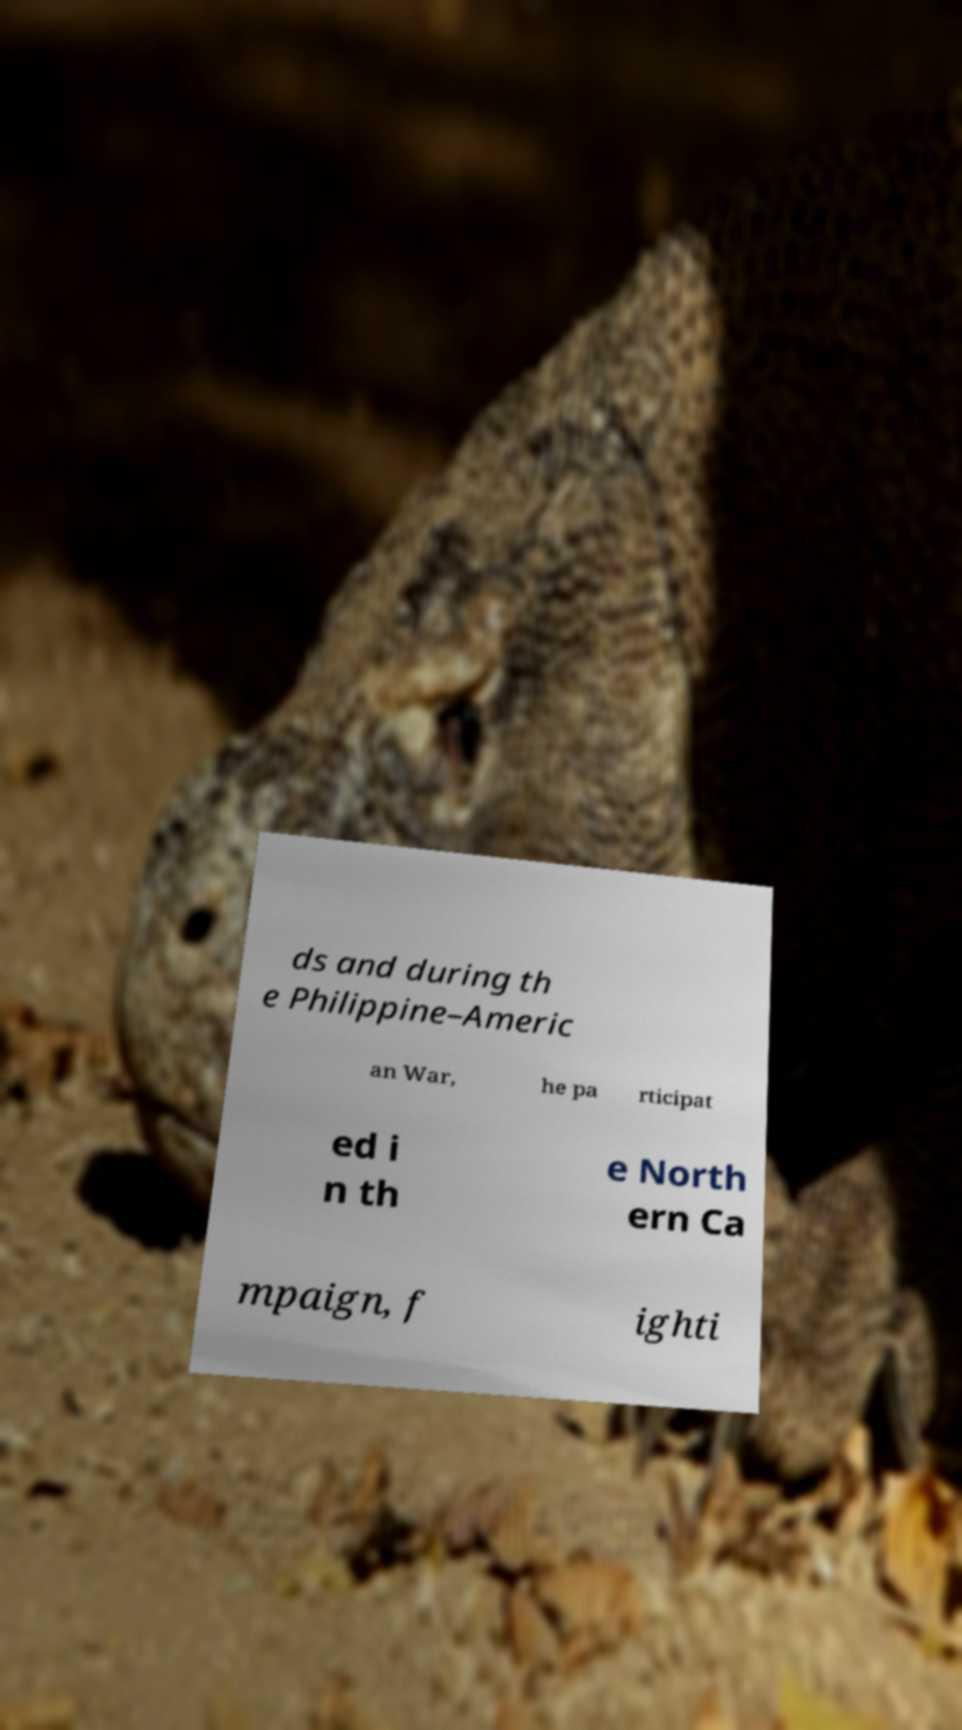I need the written content from this picture converted into text. Can you do that? ds and during th e Philippine–Americ an War, he pa rticipat ed i n th e North ern Ca mpaign, f ighti 